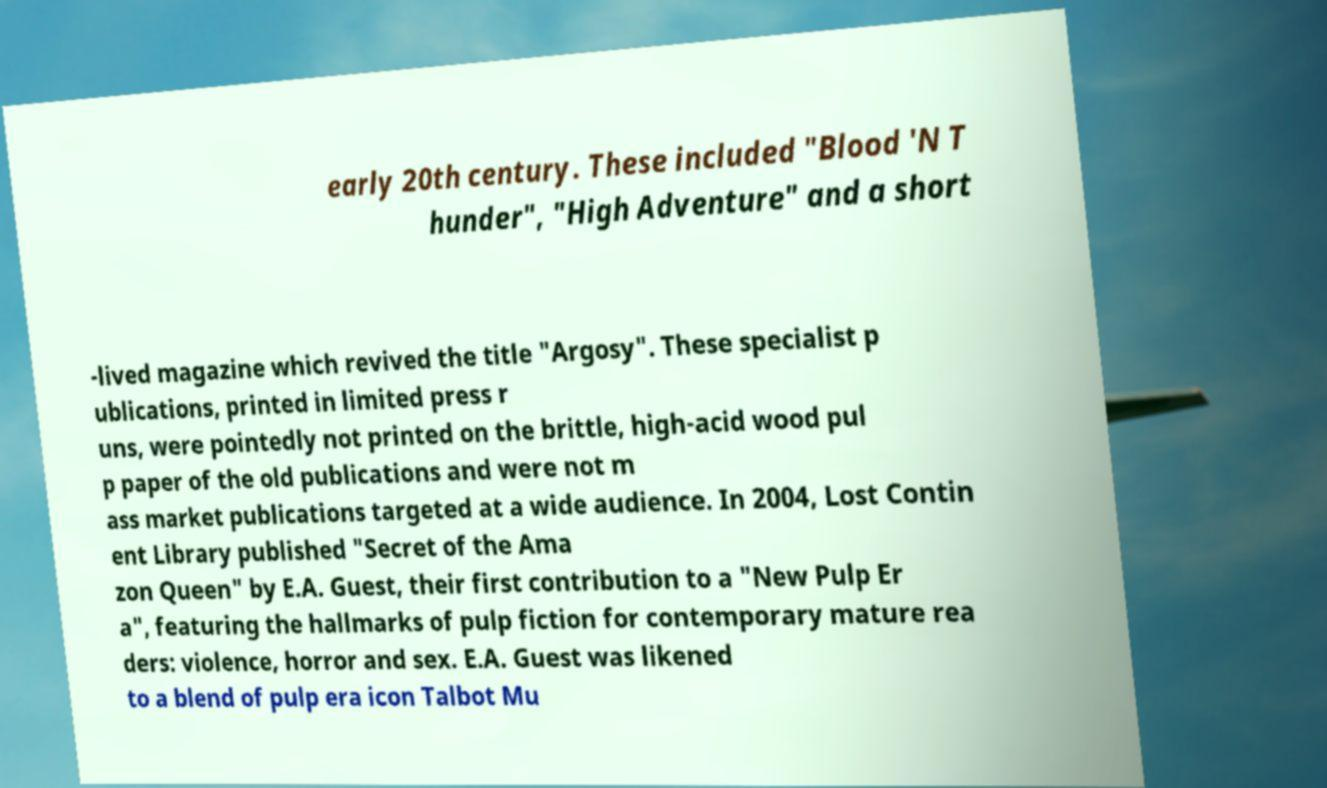There's text embedded in this image that I need extracted. Can you transcribe it verbatim? early 20th century. These included "Blood 'N T hunder", "High Adventure" and a short -lived magazine which revived the title "Argosy". These specialist p ublications, printed in limited press r uns, were pointedly not printed on the brittle, high-acid wood pul p paper of the old publications and were not m ass market publications targeted at a wide audience. In 2004, Lost Contin ent Library published "Secret of the Ama zon Queen" by E.A. Guest, their first contribution to a "New Pulp Er a", featuring the hallmarks of pulp fiction for contemporary mature rea ders: violence, horror and sex. E.A. Guest was likened to a blend of pulp era icon Talbot Mu 